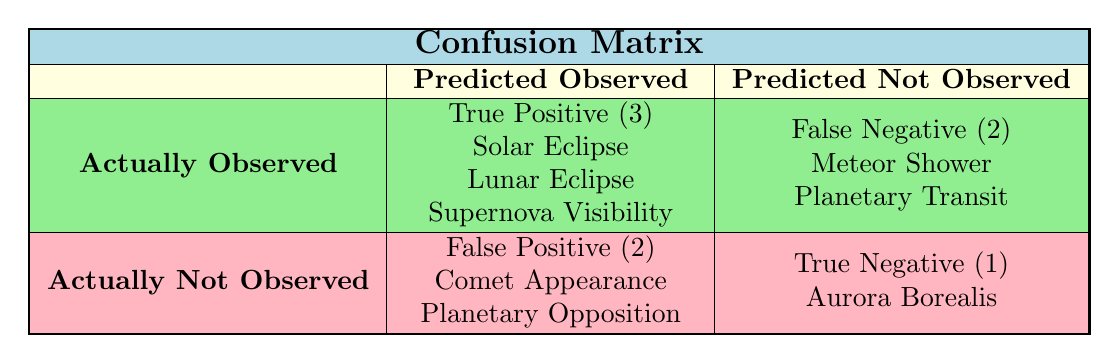What astronomical events were true positives in this data? The table shows that True Positives are events that were predicted to be observed and were actually observed. From the table, the True Positives are Solar Eclipse, Lunar Eclipse, and Supernova Visibility.
Answer: Solar Eclipse, Lunar Eclipse, Supernova Visibility How many false negatives are reported in the confusion matrix? The False Negatives are events that were predicted as not observed but were actually observed. The table lists Meteor Shower and Planetary Transit as False Negatives, totaling 2 events.
Answer: 2 What is the total number of predicted observed events? To find the total number of predicted observed events, we consider both True Positives and False Positives. The True Positives are 3 (Solar Eclipse, Lunar Eclipse, Supernova Visibility) and the False Positives are 2 (Comet Appearance, Planetary Opposition). So, the total is 3 + 2 = 5.
Answer: 5 Did the Planetary Transit event turn out to be a True Positive? According to the table, Planetary Transit was predicted as Not Observed and was classified as a False Negative. Therefore, it cannot be a True Positive.
Answer: No Which event had the outcome of True Negative and what does that mean? The event with the outcome of True Negative is Aurora Borealis. A True Negative indicates that the event was predicted as Not Observed and was actually not observed, which means the prediction was correct.
Answer: Aurora Borealis What is the ratio of True Positives to False Positives? The True Positives are 3 (Solar Eclipse, Lunar Eclipse, Supernova Visibility) and the False Positives are 2 (Comet Appearance, Planetary Opposition). The ratio of True Positives to False Positives is 3:2, which can be expressed as 3/2.
Answer: 3:2 Which astronomical event had a prediction of "Not Observed" and was actually observed? According to the table, the events that were predicted as Not Observed are Planetary Transit (False Negative) and Meteor Shower (False Negative), indicating neither was observed. Therefore, there are no events predicted as Not Observed that were actually observed.
Answer: None If we combine the True Positives and True Negatives, what is the total? The True Positives are 3 (Solar Eclipse, Lunar Eclipse, Supernova Visibility) and the True Negative is 1 (Aurora Borealis). Adding them together gives us a total of 3 + 1 = 4.
Answer: 4 